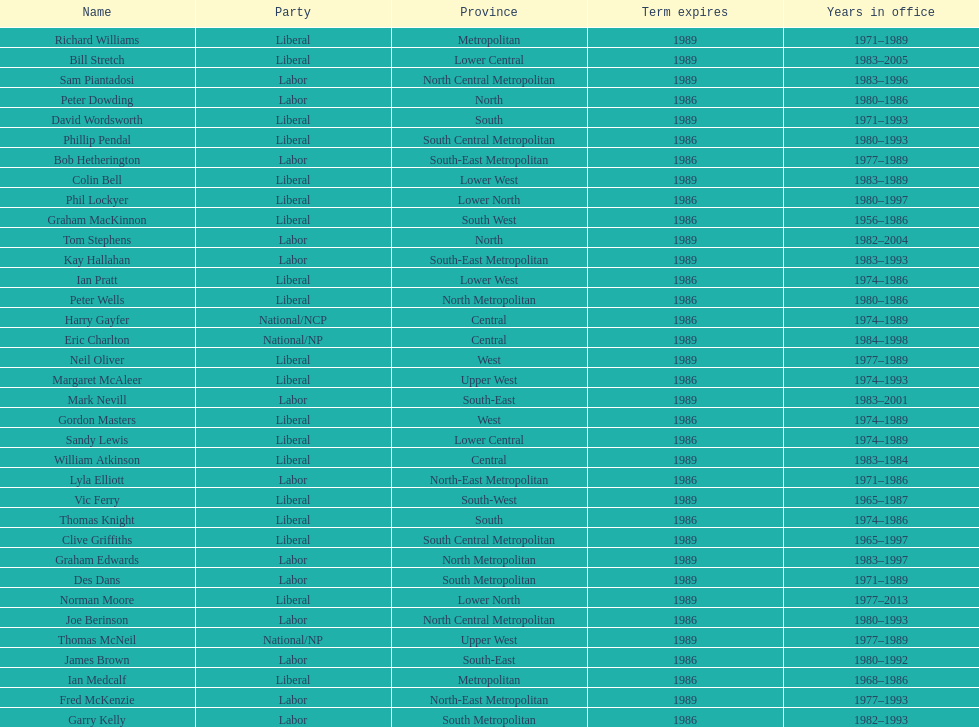How many members were party of lower west province? 2. 